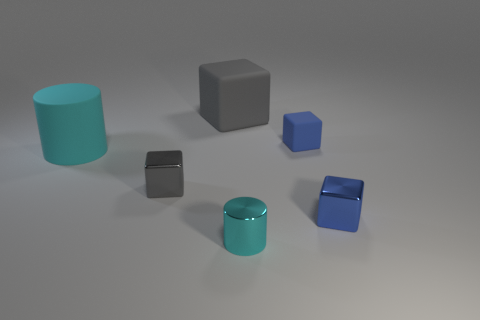What is the material of the small cyan thing?
Offer a terse response. Metal. What color is the big thing behind the big cyan matte cylinder?
Make the answer very short. Gray. What number of big things are brown shiny cylinders or gray shiny objects?
Offer a very short reply. 0. Do the big object that is in front of the large gray rubber cube and the cylinder on the right side of the big matte cylinder have the same color?
Your answer should be very brief. Yes. What number of other objects are the same color as the large matte cylinder?
Give a very brief answer. 1. How many brown things are small objects or big things?
Offer a very short reply. 0. There is a blue matte object; is its shape the same as the cyan object behind the blue metal block?
Your response must be concise. No. What is the shape of the cyan matte object?
Your response must be concise. Cylinder. What material is the cube that is the same size as the rubber cylinder?
Offer a very short reply. Rubber. Are there any other things that are the same size as the gray metallic block?
Make the answer very short. Yes. 